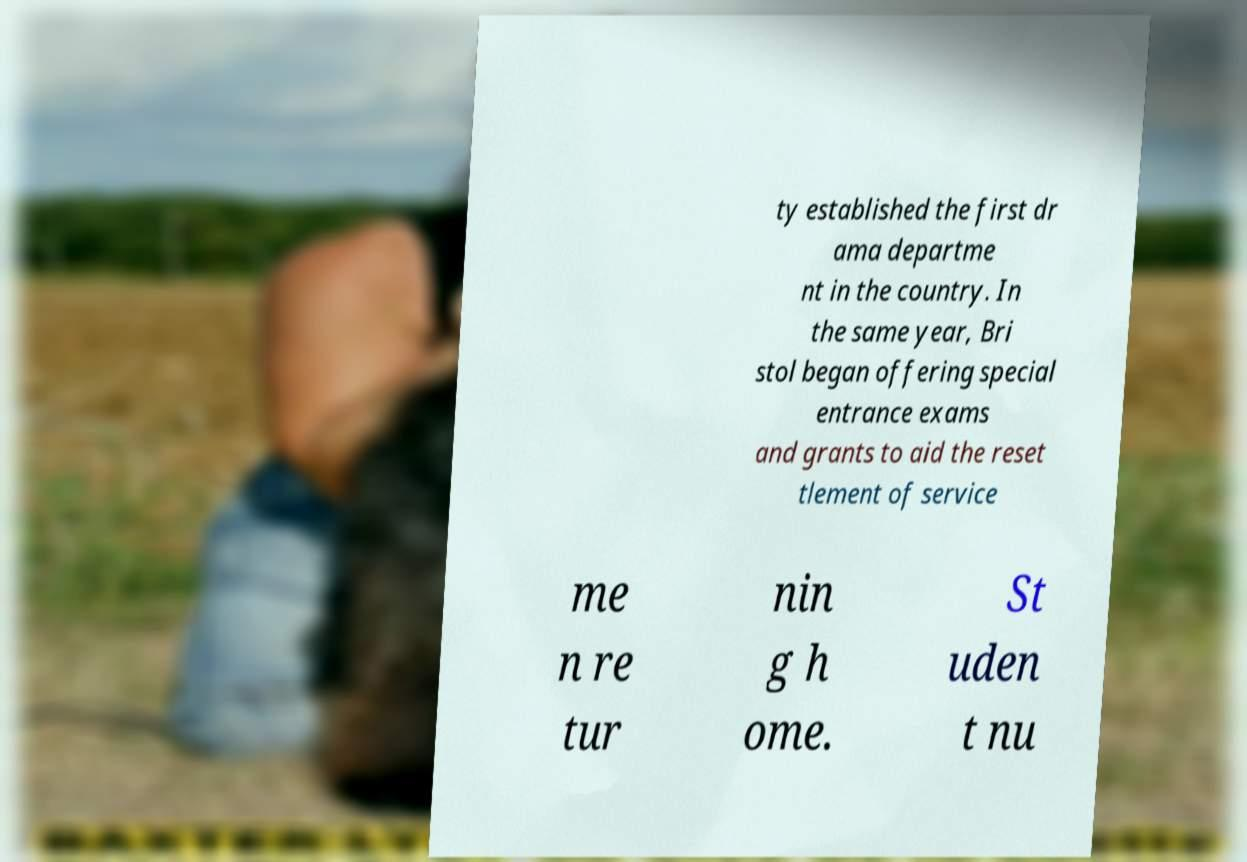For documentation purposes, I need the text within this image transcribed. Could you provide that? ty established the first dr ama departme nt in the country. In the same year, Bri stol began offering special entrance exams and grants to aid the reset tlement of service me n re tur nin g h ome. St uden t nu 